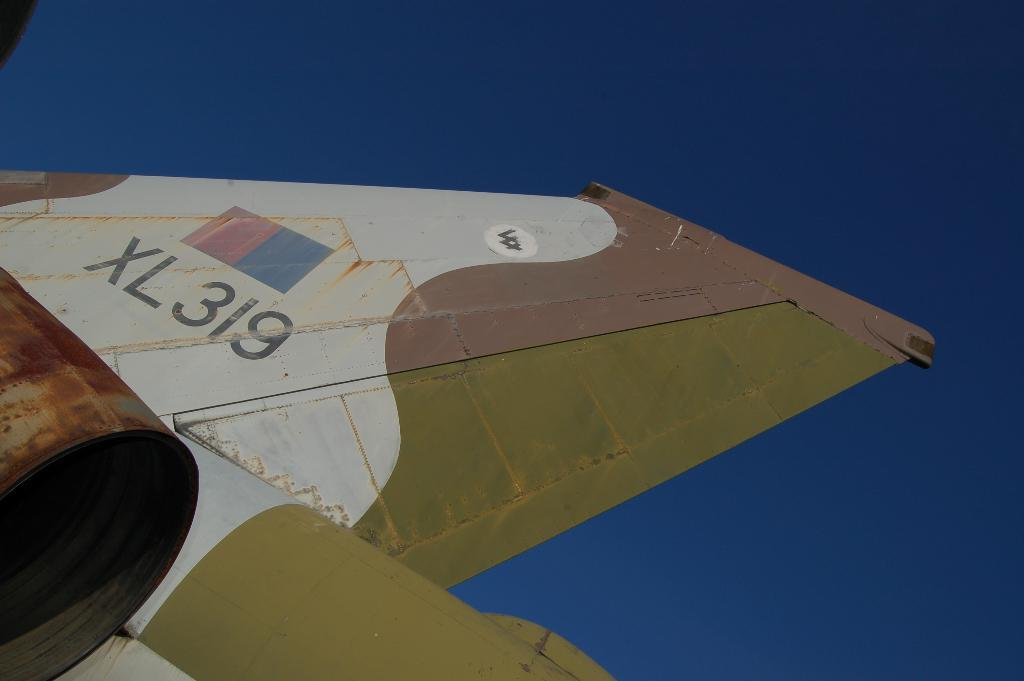<image>
Relay a brief, clear account of the picture shown. The airplane wing has letters and numbers XL319. 